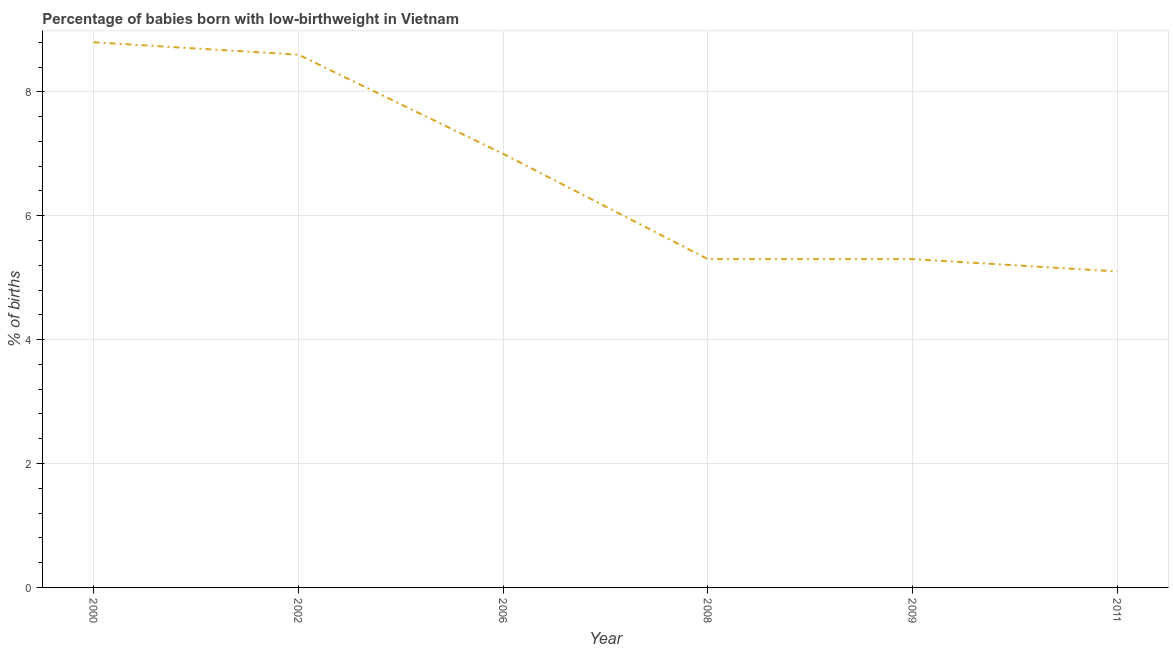What is the sum of the percentage of babies who were born with low-birthweight?
Keep it short and to the point. 40.1. What is the difference between the percentage of babies who were born with low-birthweight in 2008 and 2011?
Offer a very short reply. 0.2. What is the average percentage of babies who were born with low-birthweight per year?
Ensure brevity in your answer.  6.68. What is the median percentage of babies who were born with low-birthweight?
Provide a succinct answer. 6.15. Do a majority of the years between 2009 and 2006 (inclusive) have percentage of babies who were born with low-birthweight greater than 2.4 %?
Offer a terse response. No. What is the ratio of the percentage of babies who were born with low-birthweight in 2000 to that in 2002?
Your answer should be compact. 1.02. Is the percentage of babies who were born with low-birthweight in 2006 less than that in 2011?
Give a very brief answer. No. Is the difference between the percentage of babies who were born with low-birthweight in 2002 and 2008 greater than the difference between any two years?
Your response must be concise. No. What is the difference between the highest and the second highest percentage of babies who were born with low-birthweight?
Your response must be concise. 0.2. Is the sum of the percentage of babies who were born with low-birthweight in 2000 and 2008 greater than the maximum percentage of babies who were born with low-birthweight across all years?
Ensure brevity in your answer.  Yes. What is the difference between the highest and the lowest percentage of babies who were born with low-birthweight?
Make the answer very short. 3.7. In how many years, is the percentage of babies who were born with low-birthweight greater than the average percentage of babies who were born with low-birthweight taken over all years?
Offer a terse response. 3. What is the difference between two consecutive major ticks on the Y-axis?
Provide a short and direct response. 2. Does the graph contain any zero values?
Provide a succinct answer. No. Does the graph contain grids?
Offer a very short reply. Yes. What is the title of the graph?
Offer a very short reply. Percentage of babies born with low-birthweight in Vietnam. What is the label or title of the X-axis?
Keep it short and to the point. Year. What is the label or title of the Y-axis?
Give a very brief answer. % of births. What is the % of births of 2002?
Make the answer very short. 8.6. What is the % of births in 2006?
Provide a succinct answer. 7. What is the % of births of 2008?
Keep it short and to the point. 5.3. What is the % of births in 2009?
Offer a terse response. 5.3. What is the % of births in 2011?
Provide a short and direct response. 5.1. What is the difference between the % of births in 2000 and 2002?
Your answer should be compact. 0.2. What is the difference between the % of births in 2000 and 2006?
Offer a terse response. 1.8. What is the difference between the % of births in 2000 and 2008?
Your answer should be very brief. 3.5. What is the difference between the % of births in 2002 and 2008?
Provide a short and direct response. 3.3. What is the difference between the % of births in 2002 and 2009?
Provide a short and direct response. 3.3. What is the difference between the % of births in 2008 and 2011?
Keep it short and to the point. 0.2. What is the ratio of the % of births in 2000 to that in 2002?
Your answer should be compact. 1.02. What is the ratio of the % of births in 2000 to that in 2006?
Provide a succinct answer. 1.26. What is the ratio of the % of births in 2000 to that in 2008?
Ensure brevity in your answer.  1.66. What is the ratio of the % of births in 2000 to that in 2009?
Your response must be concise. 1.66. What is the ratio of the % of births in 2000 to that in 2011?
Your answer should be compact. 1.73. What is the ratio of the % of births in 2002 to that in 2006?
Your answer should be very brief. 1.23. What is the ratio of the % of births in 2002 to that in 2008?
Your answer should be very brief. 1.62. What is the ratio of the % of births in 2002 to that in 2009?
Offer a very short reply. 1.62. What is the ratio of the % of births in 2002 to that in 2011?
Make the answer very short. 1.69. What is the ratio of the % of births in 2006 to that in 2008?
Your answer should be very brief. 1.32. What is the ratio of the % of births in 2006 to that in 2009?
Your response must be concise. 1.32. What is the ratio of the % of births in 2006 to that in 2011?
Offer a terse response. 1.37. What is the ratio of the % of births in 2008 to that in 2009?
Offer a terse response. 1. What is the ratio of the % of births in 2008 to that in 2011?
Ensure brevity in your answer.  1.04. What is the ratio of the % of births in 2009 to that in 2011?
Provide a short and direct response. 1.04. 